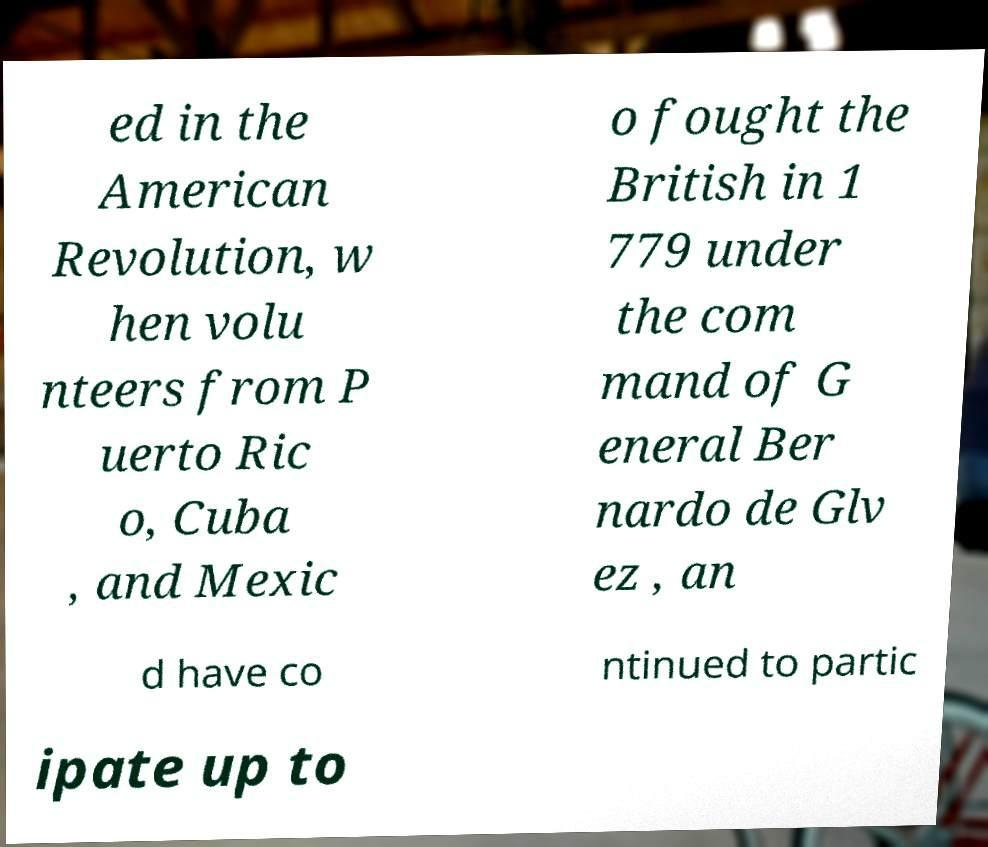Please read and relay the text visible in this image. What does it say? ed in the American Revolution, w hen volu nteers from P uerto Ric o, Cuba , and Mexic o fought the British in 1 779 under the com mand of G eneral Ber nardo de Glv ez , an d have co ntinued to partic ipate up to 